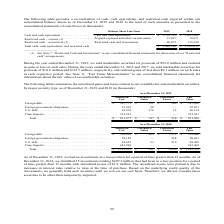According to First Solar's financial document, What amount of proceeds was derived from selling marketable securities in 2019? During the year ended December 31, 2019, we sold marketable securities for proceeds of $52.0 million and realized no gain or loss on such sales.. The document states: "During the year ended December 31, 2019, we sold marketable securities for proceeds of $52.0 million and realized no gain or loss on such sales. Durin..." Also, How many investments were at loss positions for greater than 12 months as at 31 December 2018? According to the financial document, 15. The relevant text states: "12 months. As of December 31, 2018, we identified 15 investments totaling $207.2 million that had been in a loss position for a period of time greater t..." Also, What were the reasons for the unrealized losses as at 31 December 2018? The unrealized losses were primarily due to increases in interest rates relative to rates at the time of purchase.. The document states: "12 months with unrealized losses of $1.8 million. The unrealized losses were primarily due to increases in interest rates relative to rates at the tim..." Also, can you calculate: What percentage of the total amortized marketable securities is made up of amortized foreign debt? Based on the calculation: 387,775 / 811,277 , the result is 47.8 (percentage). This is based on the information: "34 Time deposits . 335,541 — — 335,541 Total. . $ 811,277 $ 747 $ 518 $ 811,506 ins Unrealized Losses Fair Value Foreign debt . $ 387,775 $ 551 $ 506 $ 387,820 Foreign government obligations. . 21,991..." The key data points involved are: 387,775, 811,277. Also, can you calculate: What is the net gain/loss for U.S. debt? Based on the calculation: 176 - 12 , the result is 164 (in thousands). This is based on the information: "ions. . 21,991 20 — 22,011 U.S. debt . 65,970 176 12 66,134 Time deposits . 335,541 — — 335,541 Total. . $ 811,277 $ 747 $ 518 $ 811,506 igations. . 21,991 20 — 22,011 U.S. debt . 65,970 176 12 66,134..." The key data points involved are: 12, 176. Also, can you calculate: What percentage of the total fair value marketable securities is made up of fair value time deposits? Based on the calculation: 335,541 / 811,506 , the result is 41.35 (percentage). This is based on the information: "U.S. debt . 65,970 176 12 66,134 Time deposits . 335,541 — — 335,541 Total. . $ 811,277 $ 747 $ 518 $ 811,506 ,541 — — 335,541 Total. . $ 811,277 $ 747 $ 518 $ 811,506..." The key data points involved are: 335,541, 811,506. 